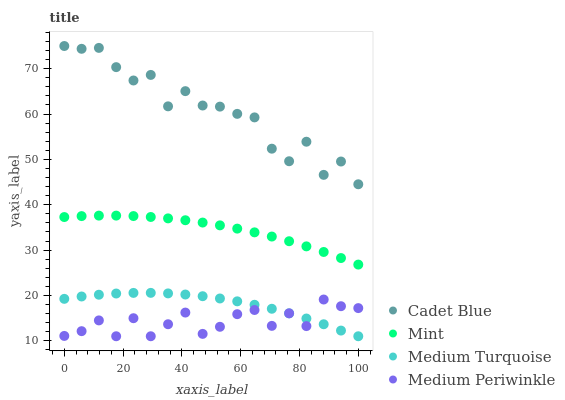Does Medium Periwinkle have the minimum area under the curve?
Answer yes or no. Yes. Does Cadet Blue have the maximum area under the curve?
Answer yes or no. Yes. Does Mint have the minimum area under the curve?
Answer yes or no. No. Does Mint have the maximum area under the curve?
Answer yes or no. No. Is Mint the smoothest?
Answer yes or no. Yes. Is Cadet Blue the roughest?
Answer yes or no. Yes. Is Cadet Blue the smoothest?
Answer yes or no. No. Is Mint the roughest?
Answer yes or no. No. Does Medium Periwinkle have the lowest value?
Answer yes or no. Yes. Does Mint have the lowest value?
Answer yes or no. No. Does Cadet Blue have the highest value?
Answer yes or no. Yes. Does Mint have the highest value?
Answer yes or no. No. Is Mint less than Cadet Blue?
Answer yes or no. Yes. Is Cadet Blue greater than Medium Periwinkle?
Answer yes or no. Yes. Does Medium Periwinkle intersect Medium Turquoise?
Answer yes or no. Yes. Is Medium Periwinkle less than Medium Turquoise?
Answer yes or no. No. Is Medium Periwinkle greater than Medium Turquoise?
Answer yes or no. No. Does Mint intersect Cadet Blue?
Answer yes or no. No. 